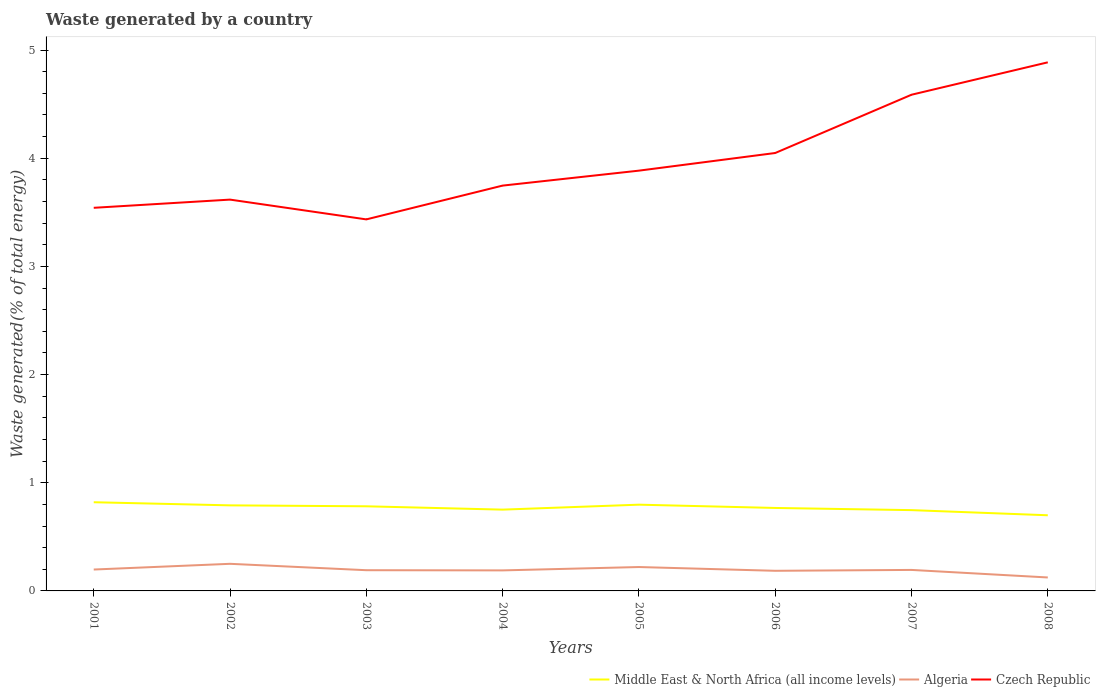Does the line corresponding to Algeria intersect with the line corresponding to Czech Republic?
Your answer should be very brief. No. Across all years, what is the maximum total waste generated in Algeria?
Provide a short and direct response. 0.12. In which year was the total waste generated in Middle East & North Africa (all income levels) maximum?
Your answer should be compact. 2008. What is the total total waste generated in Middle East & North Africa (all income levels) in the graph?
Provide a succinct answer. 0.03. What is the difference between the highest and the second highest total waste generated in Middle East & North Africa (all income levels)?
Provide a succinct answer. 0.12. How many years are there in the graph?
Give a very brief answer. 8. What is the difference between two consecutive major ticks on the Y-axis?
Your answer should be compact. 1. Where does the legend appear in the graph?
Provide a succinct answer. Bottom right. How many legend labels are there?
Your answer should be very brief. 3. How are the legend labels stacked?
Ensure brevity in your answer.  Horizontal. What is the title of the graph?
Offer a very short reply. Waste generated by a country. Does "Thailand" appear as one of the legend labels in the graph?
Offer a very short reply. No. What is the label or title of the Y-axis?
Give a very brief answer. Waste generated(% of total energy). What is the Waste generated(% of total energy) in Middle East & North Africa (all income levels) in 2001?
Your answer should be compact. 0.82. What is the Waste generated(% of total energy) of Algeria in 2001?
Provide a succinct answer. 0.2. What is the Waste generated(% of total energy) in Czech Republic in 2001?
Your answer should be very brief. 3.54. What is the Waste generated(% of total energy) in Middle East & North Africa (all income levels) in 2002?
Provide a short and direct response. 0.79. What is the Waste generated(% of total energy) in Algeria in 2002?
Ensure brevity in your answer.  0.25. What is the Waste generated(% of total energy) of Czech Republic in 2002?
Make the answer very short. 3.62. What is the Waste generated(% of total energy) in Middle East & North Africa (all income levels) in 2003?
Make the answer very short. 0.78. What is the Waste generated(% of total energy) in Algeria in 2003?
Provide a short and direct response. 0.19. What is the Waste generated(% of total energy) in Czech Republic in 2003?
Make the answer very short. 3.43. What is the Waste generated(% of total energy) of Middle East & North Africa (all income levels) in 2004?
Keep it short and to the point. 0.75. What is the Waste generated(% of total energy) in Algeria in 2004?
Offer a terse response. 0.19. What is the Waste generated(% of total energy) of Czech Republic in 2004?
Offer a very short reply. 3.75. What is the Waste generated(% of total energy) in Middle East & North Africa (all income levels) in 2005?
Give a very brief answer. 0.8. What is the Waste generated(% of total energy) in Algeria in 2005?
Offer a very short reply. 0.22. What is the Waste generated(% of total energy) in Czech Republic in 2005?
Your response must be concise. 3.88. What is the Waste generated(% of total energy) of Middle East & North Africa (all income levels) in 2006?
Your response must be concise. 0.77. What is the Waste generated(% of total energy) of Algeria in 2006?
Your answer should be very brief. 0.19. What is the Waste generated(% of total energy) of Czech Republic in 2006?
Keep it short and to the point. 4.05. What is the Waste generated(% of total energy) of Middle East & North Africa (all income levels) in 2007?
Keep it short and to the point. 0.75. What is the Waste generated(% of total energy) of Algeria in 2007?
Provide a short and direct response. 0.19. What is the Waste generated(% of total energy) of Czech Republic in 2007?
Your answer should be compact. 4.59. What is the Waste generated(% of total energy) of Middle East & North Africa (all income levels) in 2008?
Your answer should be compact. 0.7. What is the Waste generated(% of total energy) of Algeria in 2008?
Offer a terse response. 0.12. What is the Waste generated(% of total energy) in Czech Republic in 2008?
Your response must be concise. 4.89. Across all years, what is the maximum Waste generated(% of total energy) in Middle East & North Africa (all income levels)?
Your answer should be compact. 0.82. Across all years, what is the maximum Waste generated(% of total energy) in Algeria?
Provide a short and direct response. 0.25. Across all years, what is the maximum Waste generated(% of total energy) of Czech Republic?
Make the answer very short. 4.89. Across all years, what is the minimum Waste generated(% of total energy) in Middle East & North Africa (all income levels)?
Your answer should be very brief. 0.7. Across all years, what is the minimum Waste generated(% of total energy) of Algeria?
Your response must be concise. 0.12. Across all years, what is the minimum Waste generated(% of total energy) of Czech Republic?
Provide a succinct answer. 3.43. What is the total Waste generated(% of total energy) in Middle East & North Africa (all income levels) in the graph?
Offer a very short reply. 6.16. What is the total Waste generated(% of total energy) in Algeria in the graph?
Your answer should be compact. 1.55. What is the total Waste generated(% of total energy) in Czech Republic in the graph?
Make the answer very short. 31.75. What is the difference between the Waste generated(% of total energy) in Middle East & North Africa (all income levels) in 2001 and that in 2002?
Your answer should be very brief. 0.03. What is the difference between the Waste generated(% of total energy) in Algeria in 2001 and that in 2002?
Provide a short and direct response. -0.05. What is the difference between the Waste generated(% of total energy) of Czech Republic in 2001 and that in 2002?
Provide a succinct answer. -0.08. What is the difference between the Waste generated(% of total energy) in Middle East & North Africa (all income levels) in 2001 and that in 2003?
Your answer should be very brief. 0.04. What is the difference between the Waste generated(% of total energy) in Algeria in 2001 and that in 2003?
Provide a succinct answer. 0.01. What is the difference between the Waste generated(% of total energy) in Czech Republic in 2001 and that in 2003?
Keep it short and to the point. 0.11. What is the difference between the Waste generated(% of total energy) in Middle East & North Africa (all income levels) in 2001 and that in 2004?
Your answer should be very brief. 0.07. What is the difference between the Waste generated(% of total energy) of Algeria in 2001 and that in 2004?
Your answer should be very brief. 0.01. What is the difference between the Waste generated(% of total energy) in Czech Republic in 2001 and that in 2004?
Give a very brief answer. -0.21. What is the difference between the Waste generated(% of total energy) of Middle East & North Africa (all income levels) in 2001 and that in 2005?
Provide a short and direct response. 0.02. What is the difference between the Waste generated(% of total energy) in Algeria in 2001 and that in 2005?
Give a very brief answer. -0.02. What is the difference between the Waste generated(% of total energy) in Czech Republic in 2001 and that in 2005?
Keep it short and to the point. -0.34. What is the difference between the Waste generated(% of total energy) of Middle East & North Africa (all income levels) in 2001 and that in 2006?
Offer a very short reply. 0.05. What is the difference between the Waste generated(% of total energy) of Algeria in 2001 and that in 2006?
Keep it short and to the point. 0.01. What is the difference between the Waste generated(% of total energy) in Czech Republic in 2001 and that in 2006?
Provide a succinct answer. -0.51. What is the difference between the Waste generated(% of total energy) of Middle East & North Africa (all income levels) in 2001 and that in 2007?
Your response must be concise. 0.07. What is the difference between the Waste generated(% of total energy) of Algeria in 2001 and that in 2007?
Your response must be concise. 0. What is the difference between the Waste generated(% of total energy) of Czech Republic in 2001 and that in 2007?
Your answer should be compact. -1.05. What is the difference between the Waste generated(% of total energy) in Middle East & North Africa (all income levels) in 2001 and that in 2008?
Your answer should be very brief. 0.12. What is the difference between the Waste generated(% of total energy) of Algeria in 2001 and that in 2008?
Make the answer very short. 0.07. What is the difference between the Waste generated(% of total energy) in Czech Republic in 2001 and that in 2008?
Offer a very short reply. -1.34. What is the difference between the Waste generated(% of total energy) of Middle East & North Africa (all income levels) in 2002 and that in 2003?
Provide a short and direct response. 0.01. What is the difference between the Waste generated(% of total energy) in Algeria in 2002 and that in 2003?
Offer a terse response. 0.06. What is the difference between the Waste generated(% of total energy) of Czech Republic in 2002 and that in 2003?
Give a very brief answer. 0.18. What is the difference between the Waste generated(% of total energy) in Middle East & North Africa (all income levels) in 2002 and that in 2004?
Offer a terse response. 0.04. What is the difference between the Waste generated(% of total energy) of Algeria in 2002 and that in 2004?
Your answer should be very brief. 0.06. What is the difference between the Waste generated(% of total energy) in Czech Republic in 2002 and that in 2004?
Provide a succinct answer. -0.13. What is the difference between the Waste generated(% of total energy) of Middle East & North Africa (all income levels) in 2002 and that in 2005?
Give a very brief answer. -0.01. What is the difference between the Waste generated(% of total energy) of Algeria in 2002 and that in 2005?
Offer a terse response. 0.03. What is the difference between the Waste generated(% of total energy) of Czech Republic in 2002 and that in 2005?
Keep it short and to the point. -0.27. What is the difference between the Waste generated(% of total energy) in Middle East & North Africa (all income levels) in 2002 and that in 2006?
Offer a terse response. 0.02. What is the difference between the Waste generated(% of total energy) in Algeria in 2002 and that in 2006?
Give a very brief answer. 0.06. What is the difference between the Waste generated(% of total energy) in Czech Republic in 2002 and that in 2006?
Keep it short and to the point. -0.43. What is the difference between the Waste generated(% of total energy) in Middle East & North Africa (all income levels) in 2002 and that in 2007?
Offer a terse response. 0.04. What is the difference between the Waste generated(% of total energy) of Algeria in 2002 and that in 2007?
Your response must be concise. 0.06. What is the difference between the Waste generated(% of total energy) in Czech Republic in 2002 and that in 2007?
Give a very brief answer. -0.97. What is the difference between the Waste generated(% of total energy) in Middle East & North Africa (all income levels) in 2002 and that in 2008?
Make the answer very short. 0.09. What is the difference between the Waste generated(% of total energy) of Algeria in 2002 and that in 2008?
Provide a succinct answer. 0.13. What is the difference between the Waste generated(% of total energy) in Czech Republic in 2002 and that in 2008?
Your response must be concise. -1.27. What is the difference between the Waste generated(% of total energy) in Middle East & North Africa (all income levels) in 2003 and that in 2004?
Ensure brevity in your answer.  0.03. What is the difference between the Waste generated(% of total energy) in Algeria in 2003 and that in 2004?
Offer a terse response. 0. What is the difference between the Waste generated(% of total energy) of Czech Republic in 2003 and that in 2004?
Offer a terse response. -0.31. What is the difference between the Waste generated(% of total energy) in Middle East & North Africa (all income levels) in 2003 and that in 2005?
Ensure brevity in your answer.  -0.01. What is the difference between the Waste generated(% of total energy) of Algeria in 2003 and that in 2005?
Ensure brevity in your answer.  -0.03. What is the difference between the Waste generated(% of total energy) of Czech Republic in 2003 and that in 2005?
Your answer should be very brief. -0.45. What is the difference between the Waste generated(% of total energy) in Middle East & North Africa (all income levels) in 2003 and that in 2006?
Make the answer very short. 0.02. What is the difference between the Waste generated(% of total energy) of Algeria in 2003 and that in 2006?
Make the answer very short. 0.01. What is the difference between the Waste generated(% of total energy) in Czech Republic in 2003 and that in 2006?
Offer a terse response. -0.61. What is the difference between the Waste generated(% of total energy) of Middle East & North Africa (all income levels) in 2003 and that in 2007?
Ensure brevity in your answer.  0.04. What is the difference between the Waste generated(% of total energy) of Algeria in 2003 and that in 2007?
Offer a very short reply. -0. What is the difference between the Waste generated(% of total energy) in Czech Republic in 2003 and that in 2007?
Your answer should be compact. -1.15. What is the difference between the Waste generated(% of total energy) in Middle East & North Africa (all income levels) in 2003 and that in 2008?
Keep it short and to the point. 0.08. What is the difference between the Waste generated(% of total energy) in Algeria in 2003 and that in 2008?
Your answer should be compact. 0.07. What is the difference between the Waste generated(% of total energy) of Czech Republic in 2003 and that in 2008?
Offer a very short reply. -1.45. What is the difference between the Waste generated(% of total energy) in Middle East & North Africa (all income levels) in 2004 and that in 2005?
Provide a short and direct response. -0.05. What is the difference between the Waste generated(% of total energy) in Algeria in 2004 and that in 2005?
Ensure brevity in your answer.  -0.03. What is the difference between the Waste generated(% of total energy) of Czech Republic in 2004 and that in 2005?
Provide a succinct answer. -0.14. What is the difference between the Waste generated(% of total energy) of Middle East & North Africa (all income levels) in 2004 and that in 2006?
Your response must be concise. -0.02. What is the difference between the Waste generated(% of total energy) of Algeria in 2004 and that in 2006?
Offer a terse response. 0. What is the difference between the Waste generated(% of total energy) in Czech Republic in 2004 and that in 2006?
Your answer should be compact. -0.3. What is the difference between the Waste generated(% of total energy) of Middle East & North Africa (all income levels) in 2004 and that in 2007?
Ensure brevity in your answer.  0. What is the difference between the Waste generated(% of total energy) in Algeria in 2004 and that in 2007?
Offer a very short reply. -0. What is the difference between the Waste generated(% of total energy) of Czech Republic in 2004 and that in 2007?
Provide a succinct answer. -0.84. What is the difference between the Waste generated(% of total energy) of Middle East & North Africa (all income levels) in 2004 and that in 2008?
Provide a short and direct response. 0.05. What is the difference between the Waste generated(% of total energy) of Algeria in 2004 and that in 2008?
Your answer should be compact. 0.07. What is the difference between the Waste generated(% of total energy) of Czech Republic in 2004 and that in 2008?
Ensure brevity in your answer.  -1.14. What is the difference between the Waste generated(% of total energy) of Middle East & North Africa (all income levels) in 2005 and that in 2006?
Your response must be concise. 0.03. What is the difference between the Waste generated(% of total energy) of Algeria in 2005 and that in 2006?
Your response must be concise. 0.03. What is the difference between the Waste generated(% of total energy) of Czech Republic in 2005 and that in 2006?
Your response must be concise. -0.16. What is the difference between the Waste generated(% of total energy) in Middle East & North Africa (all income levels) in 2005 and that in 2007?
Your answer should be compact. 0.05. What is the difference between the Waste generated(% of total energy) of Algeria in 2005 and that in 2007?
Offer a terse response. 0.03. What is the difference between the Waste generated(% of total energy) of Czech Republic in 2005 and that in 2007?
Offer a terse response. -0.7. What is the difference between the Waste generated(% of total energy) in Middle East & North Africa (all income levels) in 2005 and that in 2008?
Make the answer very short. 0.1. What is the difference between the Waste generated(% of total energy) of Algeria in 2005 and that in 2008?
Your answer should be compact. 0.1. What is the difference between the Waste generated(% of total energy) of Czech Republic in 2005 and that in 2008?
Make the answer very short. -1. What is the difference between the Waste generated(% of total energy) of Middle East & North Africa (all income levels) in 2006 and that in 2007?
Ensure brevity in your answer.  0.02. What is the difference between the Waste generated(% of total energy) of Algeria in 2006 and that in 2007?
Your response must be concise. -0.01. What is the difference between the Waste generated(% of total energy) in Czech Republic in 2006 and that in 2007?
Your answer should be compact. -0.54. What is the difference between the Waste generated(% of total energy) in Middle East & North Africa (all income levels) in 2006 and that in 2008?
Your answer should be very brief. 0.07. What is the difference between the Waste generated(% of total energy) in Algeria in 2006 and that in 2008?
Provide a short and direct response. 0.06. What is the difference between the Waste generated(% of total energy) of Czech Republic in 2006 and that in 2008?
Your response must be concise. -0.84. What is the difference between the Waste generated(% of total energy) of Middle East & North Africa (all income levels) in 2007 and that in 2008?
Offer a very short reply. 0.05. What is the difference between the Waste generated(% of total energy) of Algeria in 2007 and that in 2008?
Your answer should be compact. 0.07. What is the difference between the Waste generated(% of total energy) of Czech Republic in 2007 and that in 2008?
Offer a terse response. -0.3. What is the difference between the Waste generated(% of total energy) in Middle East & North Africa (all income levels) in 2001 and the Waste generated(% of total energy) in Algeria in 2002?
Provide a short and direct response. 0.57. What is the difference between the Waste generated(% of total energy) of Middle East & North Africa (all income levels) in 2001 and the Waste generated(% of total energy) of Czech Republic in 2002?
Provide a short and direct response. -2.8. What is the difference between the Waste generated(% of total energy) in Algeria in 2001 and the Waste generated(% of total energy) in Czech Republic in 2002?
Provide a succinct answer. -3.42. What is the difference between the Waste generated(% of total energy) in Middle East & North Africa (all income levels) in 2001 and the Waste generated(% of total energy) in Algeria in 2003?
Your response must be concise. 0.63. What is the difference between the Waste generated(% of total energy) of Middle East & North Africa (all income levels) in 2001 and the Waste generated(% of total energy) of Czech Republic in 2003?
Your answer should be compact. -2.61. What is the difference between the Waste generated(% of total energy) in Algeria in 2001 and the Waste generated(% of total energy) in Czech Republic in 2003?
Your answer should be very brief. -3.24. What is the difference between the Waste generated(% of total energy) of Middle East & North Africa (all income levels) in 2001 and the Waste generated(% of total energy) of Algeria in 2004?
Your answer should be very brief. 0.63. What is the difference between the Waste generated(% of total energy) in Middle East & North Africa (all income levels) in 2001 and the Waste generated(% of total energy) in Czech Republic in 2004?
Your answer should be compact. -2.93. What is the difference between the Waste generated(% of total energy) of Algeria in 2001 and the Waste generated(% of total energy) of Czech Republic in 2004?
Provide a short and direct response. -3.55. What is the difference between the Waste generated(% of total energy) in Middle East & North Africa (all income levels) in 2001 and the Waste generated(% of total energy) in Algeria in 2005?
Your answer should be very brief. 0.6. What is the difference between the Waste generated(% of total energy) of Middle East & North Africa (all income levels) in 2001 and the Waste generated(% of total energy) of Czech Republic in 2005?
Make the answer very short. -3.06. What is the difference between the Waste generated(% of total energy) in Algeria in 2001 and the Waste generated(% of total energy) in Czech Republic in 2005?
Make the answer very short. -3.69. What is the difference between the Waste generated(% of total energy) of Middle East & North Africa (all income levels) in 2001 and the Waste generated(% of total energy) of Algeria in 2006?
Make the answer very short. 0.63. What is the difference between the Waste generated(% of total energy) in Middle East & North Africa (all income levels) in 2001 and the Waste generated(% of total energy) in Czech Republic in 2006?
Offer a terse response. -3.23. What is the difference between the Waste generated(% of total energy) of Algeria in 2001 and the Waste generated(% of total energy) of Czech Republic in 2006?
Keep it short and to the point. -3.85. What is the difference between the Waste generated(% of total energy) in Middle East & North Africa (all income levels) in 2001 and the Waste generated(% of total energy) in Algeria in 2007?
Offer a very short reply. 0.63. What is the difference between the Waste generated(% of total energy) in Middle East & North Africa (all income levels) in 2001 and the Waste generated(% of total energy) in Czech Republic in 2007?
Offer a terse response. -3.77. What is the difference between the Waste generated(% of total energy) of Algeria in 2001 and the Waste generated(% of total energy) of Czech Republic in 2007?
Your answer should be very brief. -4.39. What is the difference between the Waste generated(% of total energy) in Middle East & North Africa (all income levels) in 2001 and the Waste generated(% of total energy) in Algeria in 2008?
Provide a short and direct response. 0.7. What is the difference between the Waste generated(% of total energy) of Middle East & North Africa (all income levels) in 2001 and the Waste generated(% of total energy) of Czech Republic in 2008?
Your answer should be compact. -4.07. What is the difference between the Waste generated(% of total energy) in Algeria in 2001 and the Waste generated(% of total energy) in Czech Republic in 2008?
Offer a terse response. -4.69. What is the difference between the Waste generated(% of total energy) of Middle East & North Africa (all income levels) in 2002 and the Waste generated(% of total energy) of Algeria in 2003?
Make the answer very short. 0.6. What is the difference between the Waste generated(% of total energy) in Middle East & North Africa (all income levels) in 2002 and the Waste generated(% of total energy) in Czech Republic in 2003?
Your answer should be compact. -2.64. What is the difference between the Waste generated(% of total energy) of Algeria in 2002 and the Waste generated(% of total energy) of Czech Republic in 2003?
Offer a very short reply. -3.18. What is the difference between the Waste generated(% of total energy) of Middle East & North Africa (all income levels) in 2002 and the Waste generated(% of total energy) of Algeria in 2004?
Give a very brief answer. 0.6. What is the difference between the Waste generated(% of total energy) in Middle East & North Africa (all income levels) in 2002 and the Waste generated(% of total energy) in Czech Republic in 2004?
Your answer should be compact. -2.96. What is the difference between the Waste generated(% of total energy) of Algeria in 2002 and the Waste generated(% of total energy) of Czech Republic in 2004?
Your answer should be very brief. -3.5. What is the difference between the Waste generated(% of total energy) in Middle East & North Africa (all income levels) in 2002 and the Waste generated(% of total energy) in Algeria in 2005?
Provide a succinct answer. 0.57. What is the difference between the Waste generated(% of total energy) of Middle East & North Africa (all income levels) in 2002 and the Waste generated(% of total energy) of Czech Republic in 2005?
Offer a very short reply. -3.09. What is the difference between the Waste generated(% of total energy) in Algeria in 2002 and the Waste generated(% of total energy) in Czech Republic in 2005?
Give a very brief answer. -3.63. What is the difference between the Waste generated(% of total energy) of Middle East & North Africa (all income levels) in 2002 and the Waste generated(% of total energy) of Algeria in 2006?
Offer a very short reply. 0.6. What is the difference between the Waste generated(% of total energy) in Middle East & North Africa (all income levels) in 2002 and the Waste generated(% of total energy) in Czech Republic in 2006?
Make the answer very short. -3.26. What is the difference between the Waste generated(% of total energy) in Algeria in 2002 and the Waste generated(% of total energy) in Czech Republic in 2006?
Provide a succinct answer. -3.8. What is the difference between the Waste generated(% of total energy) of Middle East & North Africa (all income levels) in 2002 and the Waste generated(% of total energy) of Algeria in 2007?
Keep it short and to the point. 0.6. What is the difference between the Waste generated(% of total energy) in Middle East & North Africa (all income levels) in 2002 and the Waste generated(% of total energy) in Czech Republic in 2007?
Keep it short and to the point. -3.8. What is the difference between the Waste generated(% of total energy) of Algeria in 2002 and the Waste generated(% of total energy) of Czech Republic in 2007?
Keep it short and to the point. -4.34. What is the difference between the Waste generated(% of total energy) of Middle East & North Africa (all income levels) in 2002 and the Waste generated(% of total energy) of Algeria in 2008?
Your answer should be very brief. 0.67. What is the difference between the Waste generated(% of total energy) in Middle East & North Africa (all income levels) in 2002 and the Waste generated(% of total energy) in Czech Republic in 2008?
Your answer should be very brief. -4.1. What is the difference between the Waste generated(% of total energy) of Algeria in 2002 and the Waste generated(% of total energy) of Czech Republic in 2008?
Your response must be concise. -4.64. What is the difference between the Waste generated(% of total energy) in Middle East & North Africa (all income levels) in 2003 and the Waste generated(% of total energy) in Algeria in 2004?
Provide a succinct answer. 0.59. What is the difference between the Waste generated(% of total energy) in Middle East & North Africa (all income levels) in 2003 and the Waste generated(% of total energy) in Czech Republic in 2004?
Your answer should be very brief. -2.96. What is the difference between the Waste generated(% of total energy) in Algeria in 2003 and the Waste generated(% of total energy) in Czech Republic in 2004?
Provide a short and direct response. -3.56. What is the difference between the Waste generated(% of total energy) in Middle East & North Africa (all income levels) in 2003 and the Waste generated(% of total energy) in Algeria in 2005?
Your answer should be very brief. 0.56. What is the difference between the Waste generated(% of total energy) of Middle East & North Africa (all income levels) in 2003 and the Waste generated(% of total energy) of Czech Republic in 2005?
Ensure brevity in your answer.  -3.1. What is the difference between the Waste generated(% of total energy) of Algeria in 2003 and the Waste generated(% of total energy) of Czech Republic in 2005?
Your response must be concise. -3.69. What is the difference between the Waste generated(% of total energy) in Middle East & North Africa (all income levels) in 2003 and the Waste generated(% of total energy) in Algeria in 2006?
Your response must be concise. 0.6. What is the difference between the Waste generated(% of total energy) of Middle East & North Africa (all income levels) in 2003 and the Waste generated(% of total energy) of Czech Republic in 2006?
Your response must be concise. -3.27. What is the difference between the Waste generated(% of total energy) of Algeria in 2003 and the Waste generated(% of total energy) of Czech Republic in 2006?
Provide a succinct answer. -3.86. What is the difference between the Waste generated(% of total energy) of Middle East & North Africa (all income levels) in 2003 and the Waste generated(% of total energy) of Algeria in 2007?
Provide a short and direct response. 0.59. What is the difference between the Waste generated(% of total energy) in Middle East & North Africa (all income levels) in 2003 and the Waste generated(% of total energy) in Czech Republic in 2007?
Your answer should be compact. -3.8. What is the difference between the Waste generated(% of total energy) of Algeria in 2003 and the Waste generated(% of total energy) of Czech Republic in 2007?
Make the answer very short. -4.4. What is the difference between the Waste generated(% of total energy) of Middle East & North Africa (all income levels) in 2003 and the Waste generated(% of total energy) of Algeria in 2008?
Provide a short and direct response. 0.66. What is the difference between the Waste generated(% of total energy) in Middle East & North Africa (all income levels) in 2003 and the Waste generated(% of total energy) in Czech Republic in 2008?
Keep it short and to the point. -4.1. What is the difference between the Waste generated(% of total energy) of Algeria in 2003 and the Waste generated(% of total energy) of Czech Republic in 2008?
Provide a short and direct response. -4.69. What is the difference between the Waste generated(% of total energy) in Middle East & North Africa (all income levels) in 2004 and the Waste generated(% of total energy) in Algeria in 2005?
Your answer should be very brief. 0.53. What is the difference between the Waste generated(% of total energy) in Middle East & North Africa (all income levels) in 2004 and the Waste generated(% of total energy) in Czech Republic in 2005?
Offer a very short reply. -3.13. What is the difference between the Waste generated(% of total energy) of Algeria in 2004 and the Waste generated(% of total energy) of Czech Republic in 2005?
Offer a terse response. -3.7. What is the difference between the Waste generated(% of total energy) in Middle East & North Africa (all income levels) in 2004 and the Waste generated(% of total energy) in Algeria in 2006?
Give a very brief answer. 0.57. What is the difference between the Waste generated(% of total energy) of Middle East & North Africa (all income levels) in 2004 and the Waste generated(% of total energy) of Czech Republic in 2006?
Offer a terse response. -3.3. What is the difference between the Waste generated(% of total energy) of Algeria in 2004 and the Waste generated(% of total energy) of Czech Republic in 2006?
Provide a short and direct response. -3.86. What is the difference between the Waste generated(% of total energy) in Middle East & North Africa (all income levels) in 2004 and the Waste generated(% of total energy) in Algeria in 2007?
Provide a succinct answer. 0.56. What is the difference between the Waste generated(% of total energy) of Middle East & North Africa (all income levels) in 2004 and the Waste generated(% of total energy) of Czech Republic in 2007?
Provide a short and direct response. -3.84. What is the difference between the Waste generated(% of total energy) of Algeria in 2004 and the Waste generated(% of total energy) of Czech Republic in 2007?
Provide a short and direct response. -4.4. What is the difference between the Waste generated(% of total energy) in Middle East & North Africa (all income levels) in 2004 and the Waste generated(% of total energy) in Algeria in 2008?
Make the answer very short. 0.63. What is the difference between the Waste generated(% of total energy) of Middle East & North Africa (all income levels) in 2004 and the Waste generated(% of total energy) of Czech Republic in 2008?
Your answer should be compact. -4.13. What is the difference between the Waste generated(% of total energy) of Algeria in 2004 and the Waste generated(% of total energy) of Czech Republic in 2008?
Your answer should be compact. -4.7. What is the difference between the Waste generated(% of total energy) in Middle East & North Africa (all income levels) in 2005 and the Waste generated(% of total energy) in Algeria in 2006?
Offer a terse response. 0.61. What is the difference between the Waste generated(% of total energy) in Middle East & North Africa (all income levels) in 2005 and the Waste generated(% of total energy) in Czech Republic in 2006?
Your answer should be very brief. -3.25. What is the difference between the Waste generated(% of total energy) in Algeria in 2005 and the Waste generated(% of total energy) in Czech Republic in 2006?
Your answer should be very brief. -3.83. What is the difference between the Waste generated(% of total energy) in Middle East & North Africa (all income levels) in 2005 and the Waste generated(% of total energy) in Algeria in 2007?
Provide a short and direct response. 0.6. What is the difference between the Waste generated(% of total energy) of Middle East & North Africa (all income levels) in 2005 and the Waste generated(% of total energy) of Czech Republic in 2007?
Offer a very short reply. -3.79. What is the difference between the Waste generated(% of total energy) of Algeria in 2005 and the Waste generated(% of total energy) of Czech Republic in 2007?
Your answer should be compact. -4.37. What is the difference between the Waste generated(% of total energy) of Middle East & North Africa (all income levels) in 2005 and the Waste generated(% of total energy) of Algeria in 2008?
Offer a terse response. 0.67. What is the difference between the Waste generated(% of total energy) in Middle East & North Africa (all income levels) in 2005 and the Waste generated(% of total energy) in Czech Republic in 2008?
Your response must be concise. -4.09. What is the difference between the Waste generated(% of total energy) of Algeria in 2005 and the Waste generated(% of total energy) of Czech Republic in 2008?
Ensure brevity in your answer.  -4.67. What is the difference between the Waste generated(% of total energy) in Middle East & North Africa (all income levels) in 2006 and the Waste generated(% of total energy) in Algeria in 2007?
Give a very brief answer. 0.57. What is the difference between the Waste generated(% of total energy) in Middle East & North Africa (all income levels) in 2006 and the Waste generated(% of total energy) in Czech Republic in 2007?
Offer a terse response. -3.82. What is the difference between the Waste generated(% of total energy) in Algeria in 2006 and the Waste generated(% of total energy) in Czech Republic in 2007?
Make the answer very short. -4.4. What is the difference between the Waste generated(% of total energy) of Middle East & North Africa (all income levels) in 2006 and the Waste generated(% of total energy) of Algeria in 2008?
Give a very brief answer. 0.64. What is the difference between the Waste generated(% of total energy) in Middle East & North Africa (all income levels) in 2006 and the Waste generated(% of total energy) in Czech Republic in 2008?
Your answer should be compact. -4.12. What is the difference between the Waste generated(% of total energy) of Algeria in 2006 and the Waste generated(% of total energy) of Czech Republic in 2008?
Provide a succinct answer. -4.7. What is the difference between the Waste generated(% of total energy) in Middle East & North Africa (all income levels) in 2007 and the Waste generated(% of total energy) in Algeria in 2008?
Give a very brief answer. 0.62. What is the difference between the Waste generated(% of total energy) in Middle East & North Africa (all income levels) in 2007 and the Waste generated(% of total energy) in Czech Republic in 2008?
Make the answer very short. -4.14. What is the difference between the Waste generated(% of total energy) of Algeria in 2007 and the Waste generated(% of total energy) of Czech Republic in 2008?
Provide a short and direct response. -4.69. What is the average Waste generated(% of total energy) of Middle East & North Africa (all income levels) per year?
Provide a short and direct response. 0.77. What is the average Waste generated(% of total energy) of Algeria per year?
Your response must be concise. 0.19. What is the average Waste generated(% of total energy) in Czech Republic per year?
Make the answer very short. 3.97. In the year 2001, what is the difference between the Waste generated(% of total energy) of Middle East & North Africa (all income levels) and Waste generated(% of total energy) of Algeria?
Provide a short and direct response. 0.62. In the year 2001, what is the difference between the Waste generated(% of total energy) of Middle East & North Africa (all income levels) and Waste generated(% of total energy) of Czech Republic?
Your response must be concise. -2.72. In the year 2001, what is the difference between the Waste generated(% of total energy) of Algeria and Waste generated(% of total energy) of Czech Republic?
Provide a succinct answer. -3.34. In the year 2002, what is the difference between the Waste generated(% of total energy) in Middle East & North Africa (all income levels) and Waste generated(% of total energy) in Algeria?
Your answer should be very brief. 0.54. In the year 2002, what is the difference between the Waste generated(% of total energy) in Middle East & North Africa (all income levels) and Waste generated(% of total energy) in Czech Republic?
Keep it short and to the point. -2.83. In the year 2002, what is the difference between the Waste generated(% of total energy) of Algeria and Waste generated(% of total energy) of Czech Republic?
Your answer should be very brief. -3.37. In the year 2003, what is the difference between the Waste generated(% of total energy) of Middle East & North Africa (all income levels) and Waste generated(% of total energy) of Algeria?
Offer a very short reply. 0.59. In the year 2003, what is the difference between the Waste generated(% of total energy) in Middle East & North Africa (all income levels) and Waste generated(% of total energy) in Czech Republic?
Give a very brief answer. -2.65. In the year 2003, what is the difference between the Waste generated(% of total energy) of Algeria and Waste generated(% of total energy) of Czech Republic?
Give a very brief answer. -3.24. In the year 2004, what is the difference between the Waste generated(% of total energy) in Middle East & North Africa (all income levels) and Waste generated(% of total energy) in Algeria?
Make the answer very short. 0.56. In the year 2004, what is the difference between the Waste generated(% of total energy) in Middle East & North Africa (all income levels) and Waste generated(% of total energy) in Czech Republic?
Ensure brevity in your answer.  -3. In the year 2004, what is the difference between the Waste generated(% of total energy) in Algeria and Waste generated(% of total energy) in Czech Republic?
Offer a very short reply. -3.56. In the year 2005, what is the difference between the Waste generated(% of total energy) of Middle East & North Africa (all income levels) and Waste generated(% of total energy) of Algeria?
Your answer should be very brief. 0.58. In the year 2005, what is the difference between the Waste generated(% of total energy) in Middle East & North Africa (all income levels) and Waste generated(% of total energy) in Czech Republic?
Provide a succinct answer. -3.09. In the year 2005, what is the difference between the Waste generated(% of total energy) in Algeria and Waste generated(% of total energy) in Czech Republic?
Offer a very short reply. -3.66. In the year 2006, what is the difference between the Waste generated(% of total energy) of Middle East & North Africa (all income levels) and Waste generated(% of total energy) of Algeria?
Your answer should be compact. 0.58. In the year 2006, what is the difference between the Waste generated(% of total energy) in Middle East & North Africa (all income levels) and Waste generated(% of total energy) in Czech Republic?
Offer a very short reply. -3.28. In the year 2006, what is the difference between the Waste generated(% of total energy) in Algeria and Waste generated(% of total energy) in Czech Republic?
Provide a short and direct response. -3.86. In the year 2007, what is the difference between the Waste generated(% of total energy) of Middle East & North Africa (all income levels) and Waste generated(% of total energy) of Algeria?
Keep it short and to the point. 0.55. In the year 2007, what is the difference between the Waste generated(% of total energy) of Middle East & North Africa (all income levels) and Waste generated(% of total energy) of Czech Republic?
Provide a short and direct response. -3.84. In the year 2007, what is the difference between the Waste generated(% of total energy) of Algeria and Waste generated(% of total energy) of Czech Republic?
Keep it short and to the point. -4.39. In the year 2008, what is the difference between the Waste generated(% of total energy) in Middle East & North Africa (all income levels) and Waste generated(% of total energy) in Algeria?
Ensure brevity in your answer.  0.57. In the year 2008, what is the difference between the Waste generated(% of total energy) of Middle East & North Africa (all income levels) and Waste generated(% of total energy) of Czech Republic?
Offer a terse response. -4.19. In the year 2008, what is the difference between the Waste generated(% of total energy) in Algeria and Waste generated(% of total energy) in Czech Republic?
Your answer should be very brief. -4.76. What is the ratio of the Waste generated(% of total energy) of Middle East & North Africa (all income levels) in 2001 to that in 2002?
Offer a very short reply. 1.04. What is the ratio of the Waste generated(% of total energy) of Algeria in 2001 to that in 2002?
Keep it short and to the point. 0.79. What is the ratio of the Waste generated(% of total energy) of Czech Republic in 2001 to that in 2002?
Offer a very short reply. 0.98. What is the ratio of the Waste generated(% of total energy) of Middle East & North Africa (all income levels) in 2001 to that in 2003?
Offer a very short reply. 1.05. What is the ratio of the Waste generated(% of total energy) in Algeria in 2001 to that in 2003?
Keep it short and to the point. 1.03. What is the ratio of the Waste generated(% of total energy) of Czech Republic in 2001 to that in 2003?
Keep it short and to the point. 1.03. What is the ratio of the Waste generated(% of total energy) in Middle East & North Africa (all income levels) in 2001 to that in 2004?
Ensure brevity in your answer.  1.09. What is the ratio of the Waste generated(% of total energy) in Algeria in 2001 to that in 2004?
Your answer should be very brief. 1.04. What is the ratio of the Waste generated(% of total energy) of Czech Republic in 2001 to that in 2004?
Make the answer very short. 0.95. What is the ratio of the Waste generated(% of total energy) of Middle East & North Africa (all income levels) in 2001 to that in 2005?
Keep it short and to the point. 1.03. What is the ratio of the Waste generated(% of total energy) in Algeria in 2001 to that in 2005?
Your answer should be compact. 0.9. What is the ratio of the Waste generated(% of total energy) in Czech Republic in 2001 to that in 2005?
Offer a very short reply. 0.91. What is the ratio of the Waste generated(% of total energy) in Middle East & North Africa (all income levels) in 2001 to that in 2006?
Keep it short and to the point. 1.07. What is the ratio of the Waste generated(% of total energy) of Algeria in 2001 to that in 2006?
Your response must be concise. 1.06. What is the ratio of the Waste generated(% of total energy) of Czech Republic in 2001 to that in 2006?
Your response must be concise. 0.87. What is the ratio of the Waste generated(% of total energy) of Middle East & North Africa (all income levels) in 2001 to that in 2007?
Your answer should be very brief. 1.1. What is the ratio of the Waste generated(% of total energy) in Algeria in 2001 to that in 2007?
Keep it short and to the point. 1.02. What is the ratio of the Waste generated(% of total energy) of Czech Republic in 2001 to that in 2007?
Your answer should be compact. 0.77. What is the ratio of the Waste generated(% of total energy) of Middle East & North Africa (all income levels) in 2001 to that in 2008?
Ensure brevity in your answer.  1.17. What is the ratio of the Waste generated(% of total energy) of Algeria in 2001 to that in 2008?
Offer a terse response. 1.59. What is the ratio of the Waste generated(% of total energy) of Czech Republic in 2001 to that in 2008?
Your answer should be compact. 0.72. What is the ratio of the Waste generated(% of total energy) of Middle East & North Africa (all income levels) in 2002 to that in 2003?
Keep it short and to the point. 1.01. What is the ratio of the Waste generated(% of total energy) in Algeria in 2002 to that in 2003?
Keep it short and to the point. 1.31. What is the ratio of the Waste generated(% of total energy) in Czech Republic in 2002 to that in 2003?
Give a very brief answer. 1.05. What is the ratio of the Waste generated(% of total energy) in Middle East & North Africa (all income levels) in 2002 to that in 2004?
Your answer should be very brief. 1.05. What is the ratio of the Waste generated(% of total energy) of Algeria in 2002 to that in 2004?
Ensure brevity in your answer.  1.32. What is the ratio of the Waste generated(% of total energy) of Czech Republic in 2002 to that in 2004?
Offer a very short reply. 0.97. What is the ratio of the Waste generated(% of total energy) in Algeria in 2002 to that in 2005?
Your response must be concise. 1.13. What is the ratio of the Waste generated(% of total energy) in Czech Republic in 2002 to that in 2005?
Your answer should be compact. 0.93. What is the ratio of the Waste generated(% of total energy) in Middle East & North Africa (all income levels) in 2002 to that in 2006?
Keep it short and to the point. 1.03. What is the ratio of the Waste generated(% of total energy) of Algeria in 2002 to that in 2006?
Keep it short and to the point. 1.35. What is the ratio of the Waste generated(% of total energy) of Czech Republic in 2002 to that in 2006?
Provide a succinct answer. 0.89. What is the ratio of the Waste generated(% of total energy) of Middle East & North Africa (all income levels) in 2002 to that in 2007?
Provide a succinct answer. 1.06. What is the ratio of the Waste generated(% of total energy) of Algeria in 2002 to that in 2007?
Offer a very short reply. 1.29. What is the ratio of the Waste generated(% of total energy) of Czech Republic in 2002 to that in 2007?
Your answer should be very brief. 0.79. What is the ratio of the Waste generated(% of total energy) of Middle East & North Africa (all income levels) in 2002 to that in 2008?
Offer a terse response. 1.13. What is the ratio of the Waste generated(% of total energy) of Algeria in 2002 to that in 2008?
Keep it short and to the point. 2.01. What is the ratio of the Waste generated(% of total energy) in Czech Republic in 2002 to that in 2008?
Provide a short and direct response. 0.74. What is the ratio of the Waste generated(% of total energy) of Middle East & North Africa (all income levels) in 2003 to that in 2004?
Offer a terse response. 1.04. What is the ratio of the Waste generated(% of total energy) in Czech Republic in 2003 to that in 2004?
Keep it short and to the point. 0.92. What is the ratio of the Waste generated(% of total energy) in Middle East & North Africa (all income levels) in 2003 to that in 2005?
Provide a succinct answer. 0.98. What is the ratio of the Waste generated(% of total energy) in Algeria in 2003 to that in 2005?
Ensure brevity in your answer.  0.87. What is the ratio of the Waste generated(% of total energy) in Czech Republic in 2003 to that in 2005?
Your response must be concise. 0.88. What is the ratio of the Waste generated(% of total energy) in Middle East & North Africa (all income levels) in 2003 to that in 2006?
Offer a terse response. 1.02. What is the ratio of the Waste generated(% of total energy) of Algeria in 2003 to that in 2006?
Give a very brief answer. 1.03. What is the ratio of the Waste generated(% of total energy) in Czech Republic in 2003 to that in 2006?
Offer a very short reply. 0.85. What is the ratio of the Waste generated(% of total energy) in Middle East & North Africa (all income levels) in 2003 to that in 2007?
Offer a very short reply. 1.05. What is the ratio of the Waste generated(% of total energy) in Algeria in 2003 to that in 2007?
Make the answer very short. 0.99. What is the ratio of the Waste generated(% of total energy) of Czech Republic in 2003 to that in 2007?
Ensure brevity in your answer.  0.75. What is the ratio of the Waste generated(% of total energy) in Middle East & North Africa (all income levels) in 2003 to that in 2008?
Your answer should be very brief. 1.12. What is the ratio of the Waste generated(% of total energy) in Algeria in 2003 to that in 2008?
Give a very brief answer. 1.54. What is the ratio of the Waste generated(% of total energy) of Czech Republic in 2003 to that in 2008?
Your answer should be very brief. 0.7. What is the ratio of the Waste generated(% of total energy) in Middle East & North Africa (all income levels) in 2004 to that in 2005?
Offer a terse response. 0.94. What is the ratio of the Waste generated(% of total energy) of Algeria in 2004 to that in 2005?
Make the answer very short. 0.86. What is the ratio of the Waste generated(% of total energy) in Czech Republic in 2004 to that in 2005?
Keep it short and to the point. 0.96. What is the ratio of the Waste generated(% of total energy) of Middle East & North Africa (all income levels) in 2004 to that in 2006?
Keep it short and to the point. 0.98. What is the ratio of the Waste generated(% of total energy) in Algeria in 2004 to that in 2006?
Ensure brevity in your answer.  1.02. What is the ratio of the Waste generated(% of total energy) of Czech Republic in 2004 to that in 2006?
Your response must be concise. 0.93. What is the ratio of the Waste generated(% of total energy) in Middle East & North Africa (all income levels) in 2004 to that in 2007?
Provide a succinct answer. 1.01. What is the ratio of the Waste generated(% of total energy) of Algeria in 2004 to that in 2007?
Ensure brevity in your answer.  0.98. What is the ratio of the Waste generated(% of total energy) of Czech Republic in 2004 to that in 2007?
Provide a short and direct response. 0.82. What is the ratio of the Waste generated(% of total energy) in Middle East & North Africa (all income levels) in 2004 to that in 2008?
Provide a short and direct response. 1.07. What is the ratio of the Waste generated(% of total energy) of Algeria in 2004 to that in 2008?
Ensure brevity in your answer.  1.53. What is the ratio of the Waste generated(% of total energy) of Czech Republic in 2004 to that in 2008?
Ensure brevity in your answer.  0.77. What is the ratio of the Waste generated(% of total energy) in Middle East & North Africa (all income levels) in 2005 to that in 2006?
Offer a terse response. 1.04. What is the ratio of the Waste generated(% of total energy) of Algeria in 2005 to that in 2006?
Provide a short and direct response. 1.19. What is the ratio of the Waste generated(% of total energy) in Czech Republic in 2005 to that in 2006?
Your response must be concise. 0.96. What is the ratio of the Waste generated(% of total energy) of Middle East & North Africa (all income levels) in 2005 to that in 2007?
Offer a terse response. 1.07. What is the ratio of the Waste generated(% of total energy) of Algeria in 2005 to that in 2007?
Provide a short and direct response. 1.14. What is the ratio of the Waste generated(% of total energy) in Czech Republic in 2005 to that in 2007?
Make the answer very short. 0.85. What is the ratio of the Waste generated(% of total energy) in Middle East & North Africa (all income levels) in 2005 to that in 2008?
Provide a succinct answer. 1.14. What is the ratio of the Waste generated(% of total energy) of Algeria in 2005 to that in 2008?
Your response must be concise. 1.78. What is the ratio of the Waste generated(% of total energy) in Czech Republic in 2005 to that in 2008?
Offer a terse response. 0.8. What is the ratio of the Waste generated(% of total energy) in Middle East & North Africa (all income levels) in 2006 to that in 2007?
Your answer should be very brief. 1.03. What is the ratio of the Waste generated(% of total energy) of Czech Republic in 2006 to that in 2007?
Provide a short and direct response. 0.88. What is the ratio of the Waste generated(% of total energy) in Middle East & North Africa (all income levels) in 2006 to that in 2008?
Make the answer very short. 1.1. What is the ratio of the Waste generated(% of total energy) in Algeria in 2006 to that in 2008?
Your answer should be very brief. 1.5. What is the ratio of the Waste generated(% of total energy) in Czech Republic in 2006 to that in 2008?
Provide a short and direct response. 0.83. What is the ratio of the Waste generated(% of total energy) in Middle East & North Africa (all income levels) in 2007 to that in 2008?
Provide a succinct answer. 1.07. What is the ratio of the Waste generated(% of total energy) in Algeria in 2007 to that in 2008?
Your response must be concise. 1.56. What is the ratio of the Waste generated(% of total energy) of Czech Republic in 2007 to that in 2008?
Offer a very short reply. 0.94. What is the difference between the highest and the second highest Waste generated(% of total energy) of Middle East & North Africa (all income levels)?
Provide a succinct answer. 0.02. What is the difference between the highest and the second highest Waste generated(% of total energy) in Algeria?
Ensure brevity in your answer.  0.03. What is the difference between the highest and the second highest Waste generated(% of total energy) in Czech Republic?
Provide a short and direct response. 0.3. What is the difference between the highest and the lowest Waste generated(% of total energy) of Middle East & North Africa (all income levels)?
Provide a succinct answer. 0.12. What is the difference between the highest and the lowest Waste generated(% of total energy) in Algeria?
Offer a terse response. 0.13. What is the difference between the highest and the lowest Waste generated(% of total energy) of Czech Republic?
Make the answer very short. 1.45. 